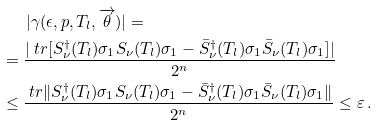Convert formula to latex. <formula><loc_0><loc_0><loc_500><loc_500>& \quad \ \ | \gamma ( \epsilon , p , T _ { l } , \overrightarrow { \theta } ) | = \\ & = \frac { | \ t r [ S ^ { \dagger } _ { \nu } ( T _ { l } ) \sigma _ { 1 } S _ { \nu } ( T _ { l } ) \sigma _ { 1 } - \bar { S } ^ { \dagger } _ { \nu } ( T _ { l } ) \sigma _ { 1 } \bar { S } _ { \nu } ( T _ { l } ) \sigma _ { 1 } ] | } { 2 ^ { n } } \\ & \leq \frac { \ t r \| S ^ { \dagger } _ { \nu } ( T _ { l } ) \sigma _ { 1 } S _ { \nu } ( T _ { l } ) \sigma _ { 1 } - \bar { S } ^ { \dagger } _ { \nu } ( T _ { l } ) \sigma _ { 1 } \bar { S } _ { \nu } ( T _ { l } ) \sigma _ { 1 } \| } { 2 ^ { n } } \leq \varepsilon \, .</formula> 